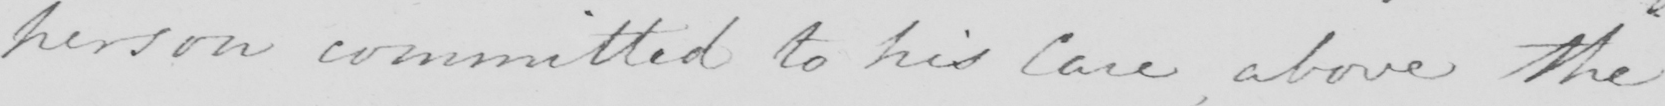Can you tell me what this handwritten text says? person committed to his Care , above the 